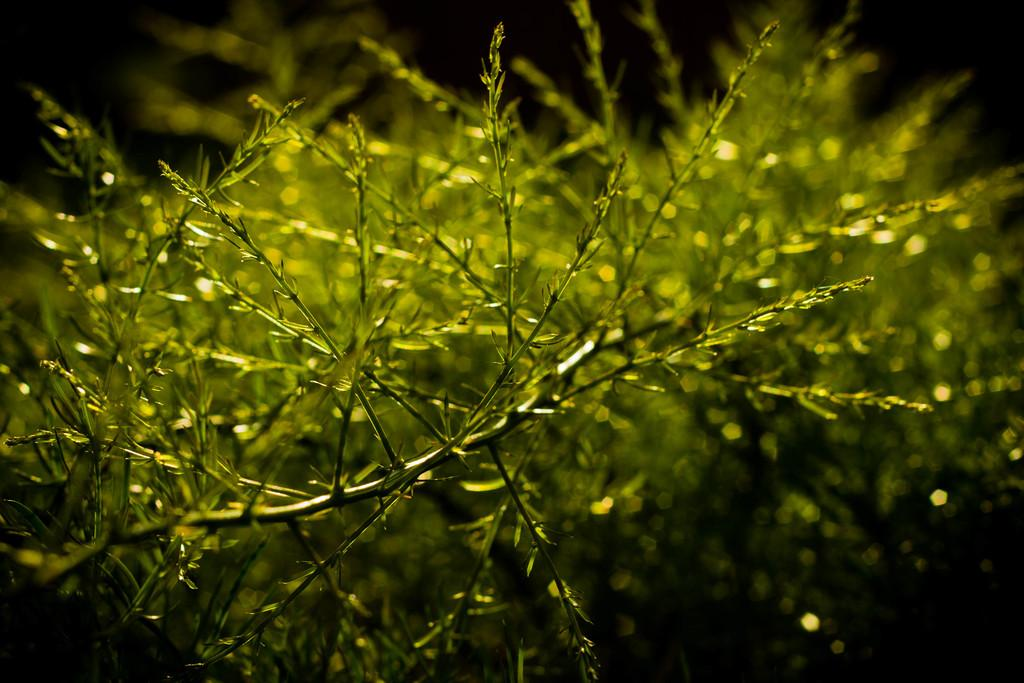What type of plants can be seen in the image? There are green color plants in the image. What color is the background of the image? The background of the image is black. What is the name of the astronaut walking in the image? There is no astronaut or walking depicted in the image; it features green color plants against a black background. 